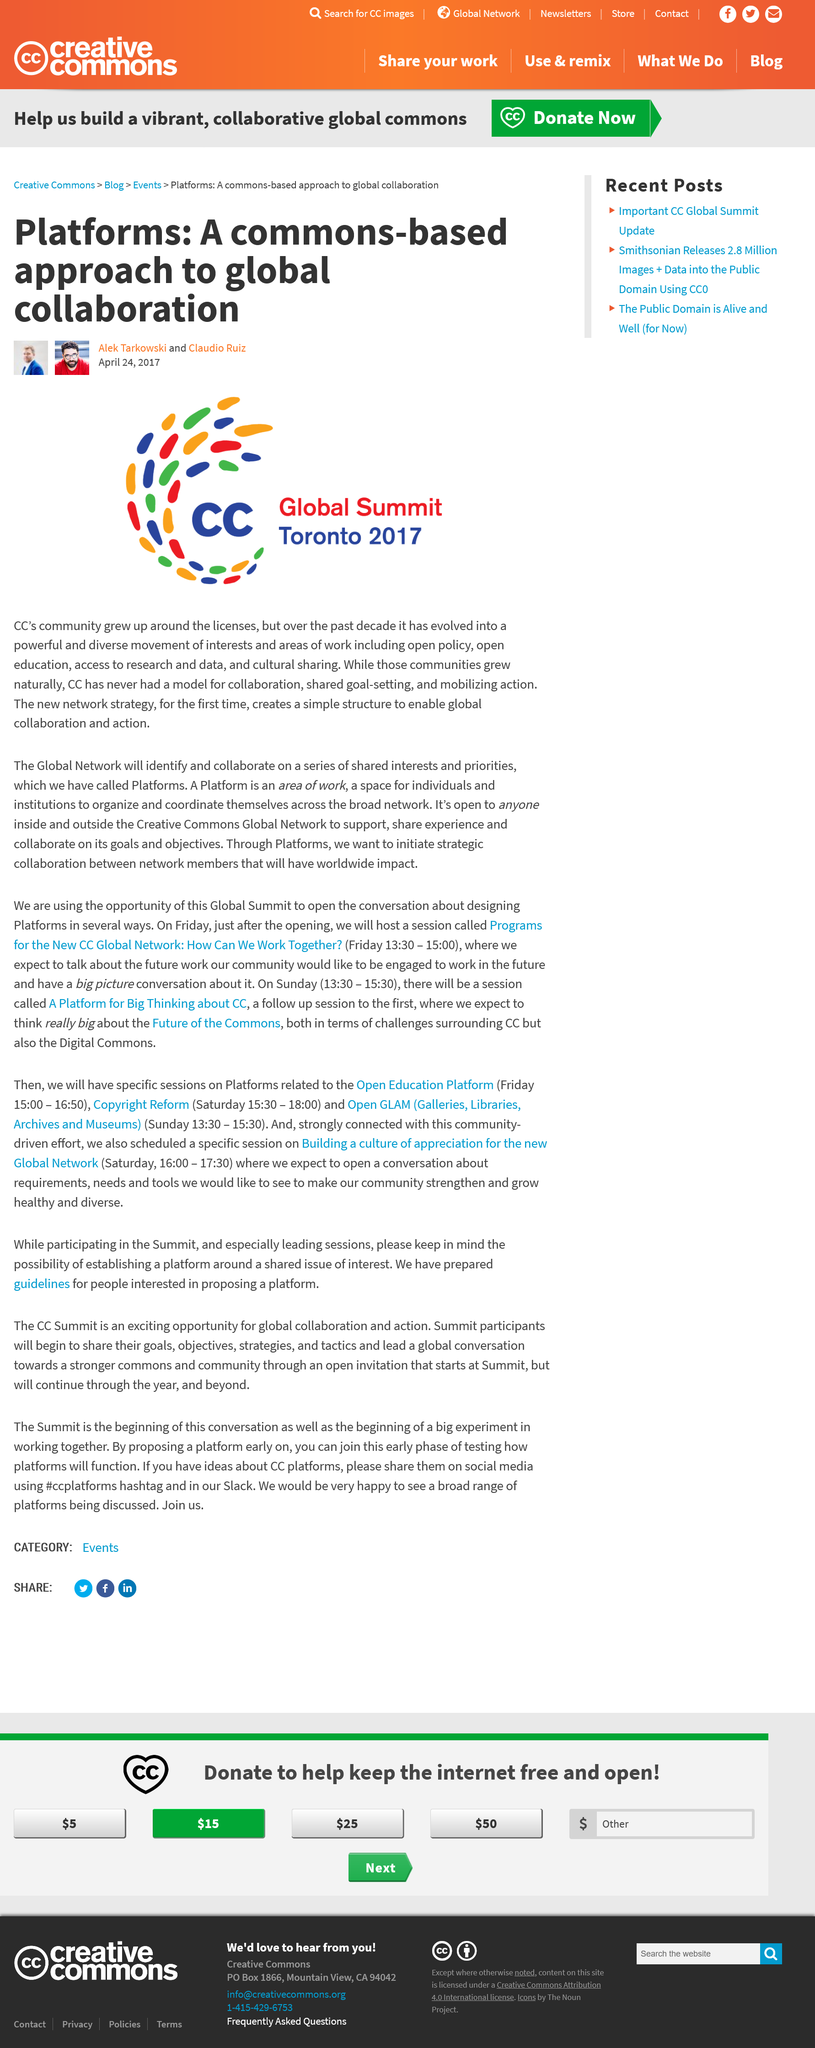Indicate a few pertinent items in this graphic. It is the case that Collaboratory Care (CC) has never had a model for collaboration, shared goal-setting, and mobilizing action. On April 24, 2017, Lek Tarkowski and Claudio Ruiz announced the platforms. Global Network will identify and collaborate with series that have a specific name. 